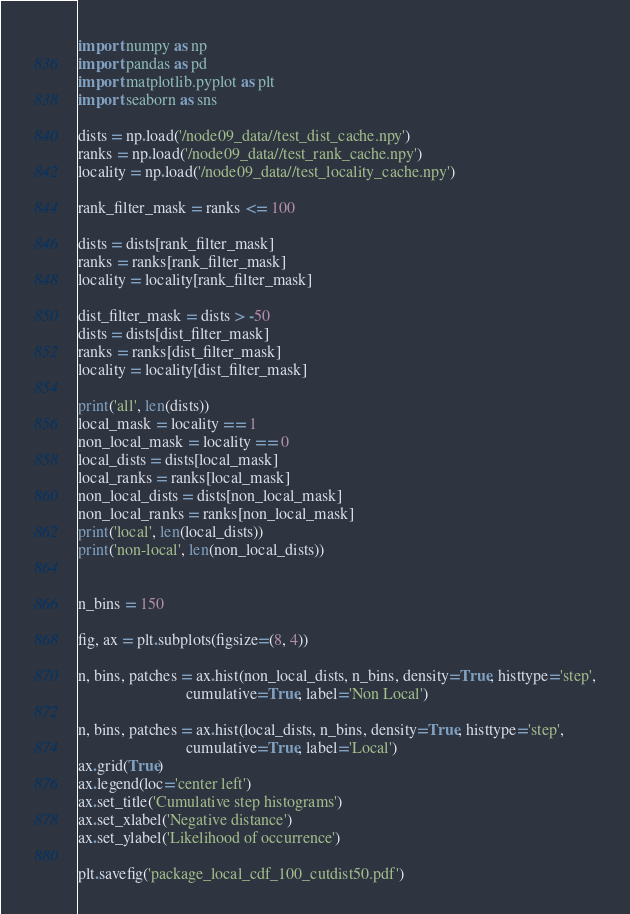Convert code to text. <code><loc_0><loc_0><loc_500><loc_500><_Python_>import numpy as np
import pandas as pd
import matplotlib.pyplot as plt
import seaborn as sns

dists = np.load('/node09_data//test_dist_cache.npy')
ranks = np.load('/node09_data//test_rank_cache.npy')
locality = np.load('/node09_data//test_locality_cache.npy')

rank_filter_mask = ranks <= 100

dists = dists[rank_filter_mask]
ranks = ranks[rank_filter_mask]
locality = locality[rank_filter_mask]

dist_filter_mask = dists > -50
dists = dists[dist_filter_mask]
ranks = ranks[dist_filter_mask]
locality = locality[dist_filter_mask]

print('all', len(dists))
local_mask = locality == 1
non_local_mask = locality == 0
local_dists = dists[local_mask]
local_ranks = ranks[local_mask]
non_local_dists = dists[non_local_mask]
non_local_ranks = ranks[non_local_mask]
print('local', len(local_dists))
print('non-local', len(non_local_dists))


n_bins = 150

fig, ax = plt.subplots(figsize=(8, 4))

n, bins, patches = ax.hist(non_local_dists, n_bins, density=True, histtype='step',
                           cumulative=True, label='Non Local')

n, bins, patches = ax.hist(local_dists, n_bins, density=True, histtype='step',
                           cumulative=True, label='Local')
ax.grid(True)
ax.legend(loc='center left')
ax.set_title('Cumulative step histograms')
ax.set_xlabel('Negative distance')
ax.set_ylabel('Likelihood of occurrence')

plt.savefig('package_local_cdf_100_cutdist50.pdf')
</code> 